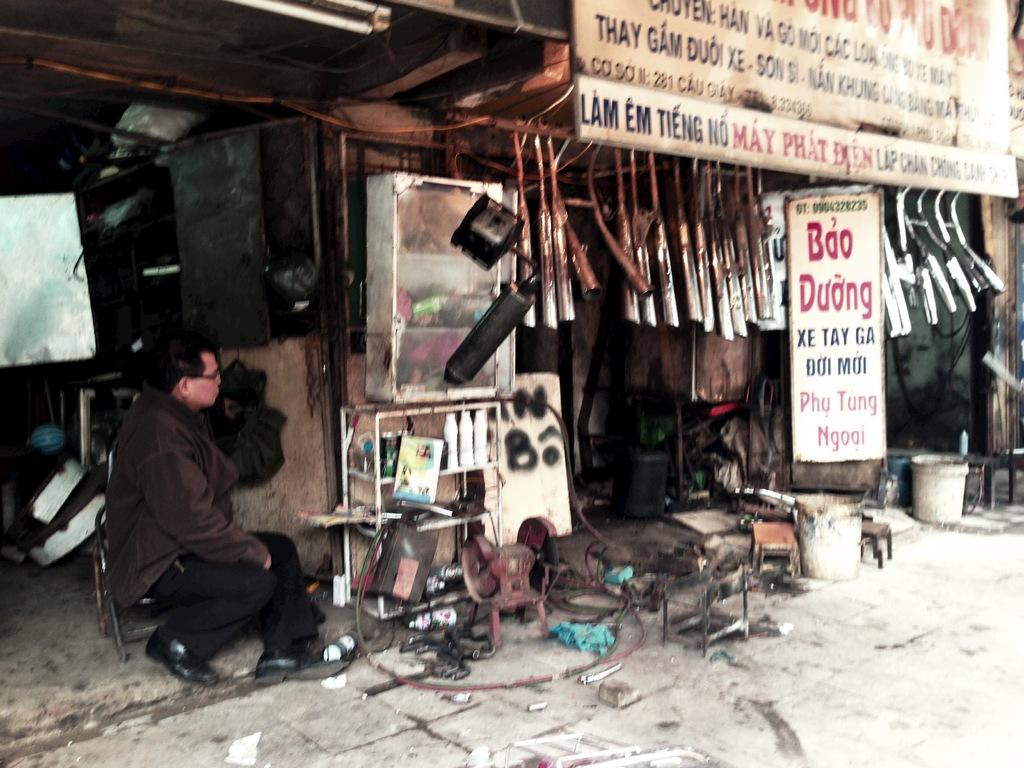What is the person in the image doing? There is a person sitting on a chair in the image. What can be seen on the boards in the image? There are boards with text in the image. What type of objects are hanging in the image? There are hanging objects in the image. What is on the floor in the image? There are objects on the floor in the image. What grade did the person in the image receive for their driving skills? There is no information about grades or driving skills in the image. 